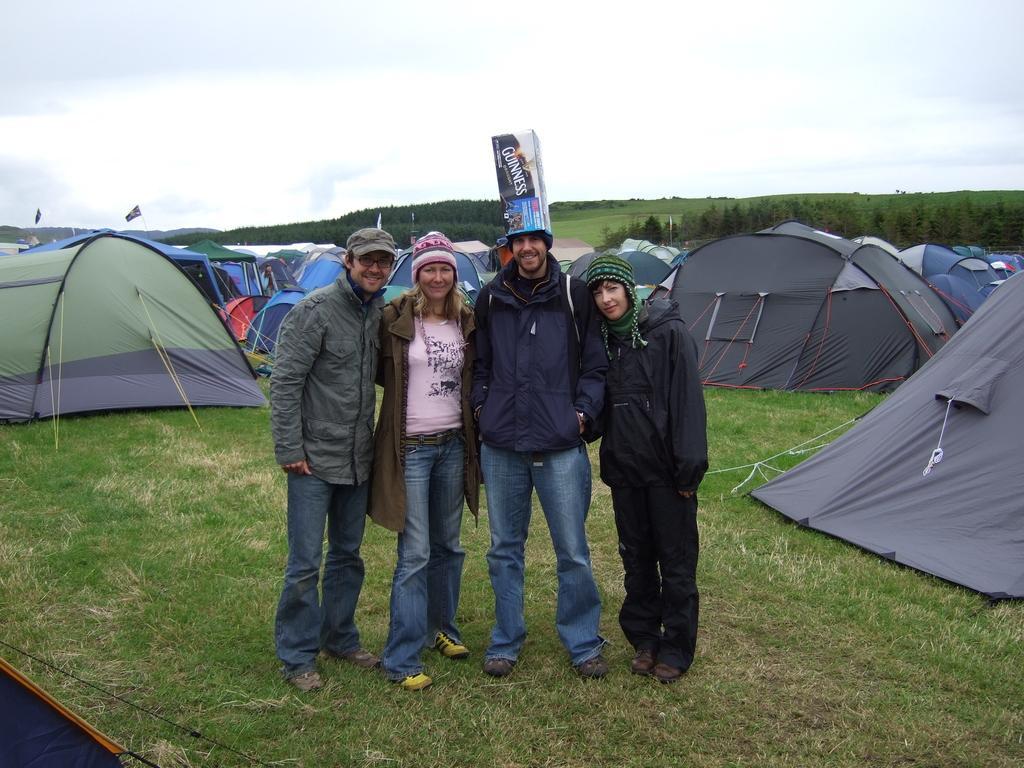Could you give a brief overview of what you see in this image? In this image, we can see four persons are standing on the grass. They are watching and smiling. Background we can see tents, trees and sky. 